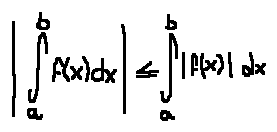<formula> <loc_0><loc_0><loc_500><loc_500>| \int \lim i t s _ { a } ^ { b } f ( x ) d x | \leq \int \lim i t s _ { a } ^ { b } | f ( x ) | d x</formula> 